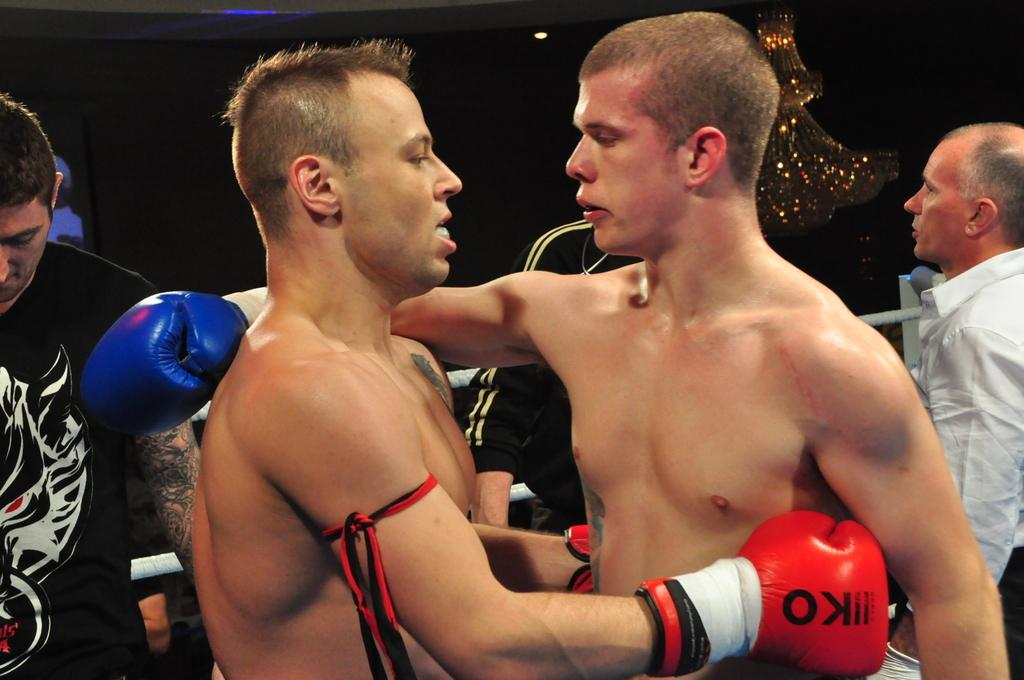<image>
Render a clear and concise summary of the photo. Two boxers embrace, the red gloves one is wearing have a KO on them. 